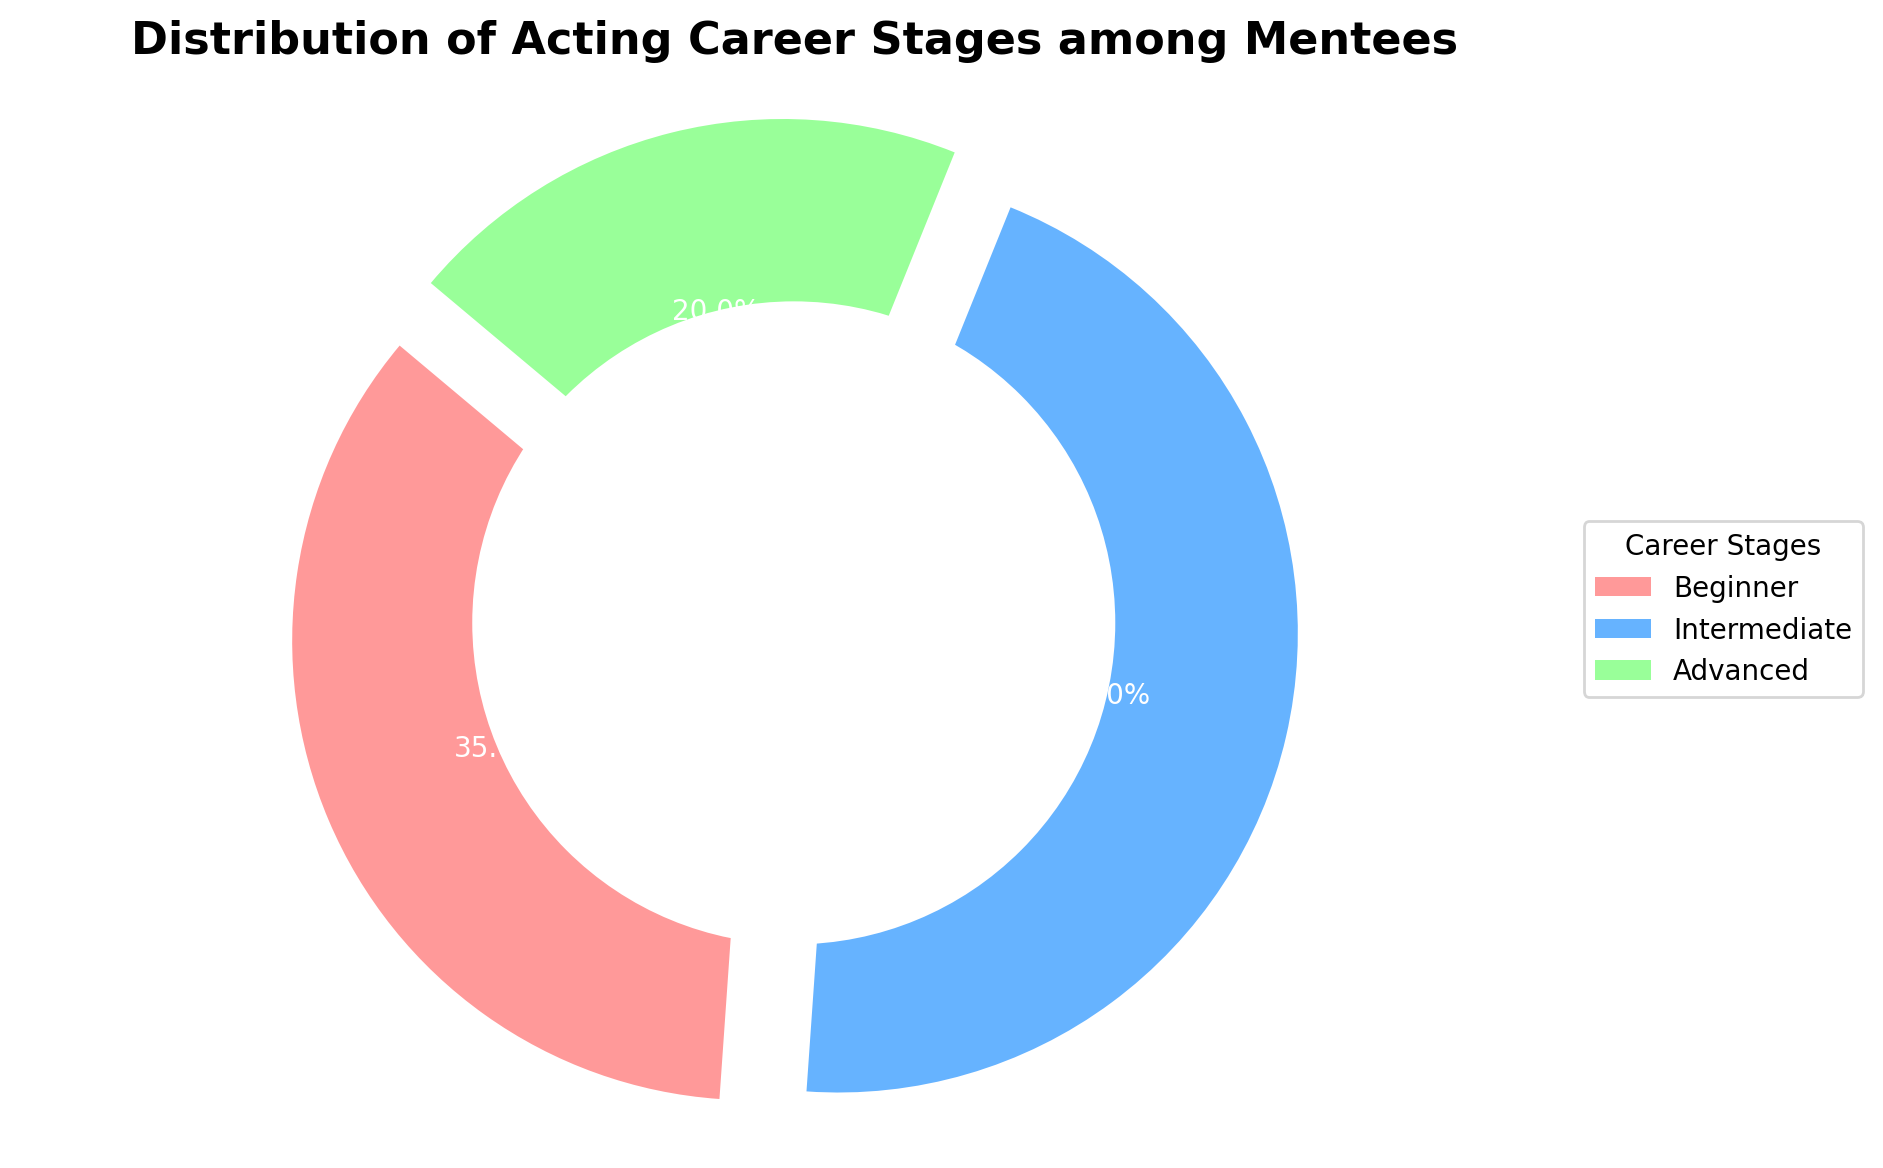What percentage of mentees are in the Advanced stage? The pie chart shows the distribution of acting career stages among mentees, and the segment labeled "Advanced" represents 20%.
Answer: 20% Which career stage has the highest percentage among mentees? To identify the career stage with the highest percentage, compare the labeled percentages of each segment. The Intermediate stage has the highest percentage, which is 45%.
Answer: Intermediate How does the percentage of Intermediate mentees compare to Advanced mentees? Comparing the slices for Intermediate and Advanced stages, we see that Intermediate has 45% and Advanced has 20%. 45% is greater than 20%.
Answer: Intermediate is greater If you sum the percentages of Intermediate and Advanced mentees, what do you get? Add the percentages for Intermediate (45%) and Advanced (20%) stages: 45% + 20% = 65%.
Answer: 65% What percentage of mentees are either Beginners or Advanced? Add the percentages for Beginners (35%) and Advanced (20%): 35% + 20% = 55%.
Answer: 55% Are there more Beginner mentees or Advanced mentees? Compare the percentages of Beginners (35%) and Advanced (20%) stages. The Beginner stage has a higher percentage at 35%.
Answer: Beginners What can you infer about the proportion of Beginner and Intermediate mentees? Comparing the percentages, the Intermediate stage has 45% while the Beginner stage has 35%. This implies there are more Intermediate mentees than Beginners.
Answer: More Intermediate Which color represents the Beginner stage on the pie chart? The pie chart segment for Beginners is colored red.
Answer: Red What is the visual attribute that makes the pie chart segments stand out? Each segment is slightly separated from the others (exploded), enhancing visual distinction.
Answer: Exploded segments How many career stages are represented in the pie chart? There are three distinct labels/categories shown around the pie chart: Beginner, Intermediate, and Advanced.
Answer: Three 